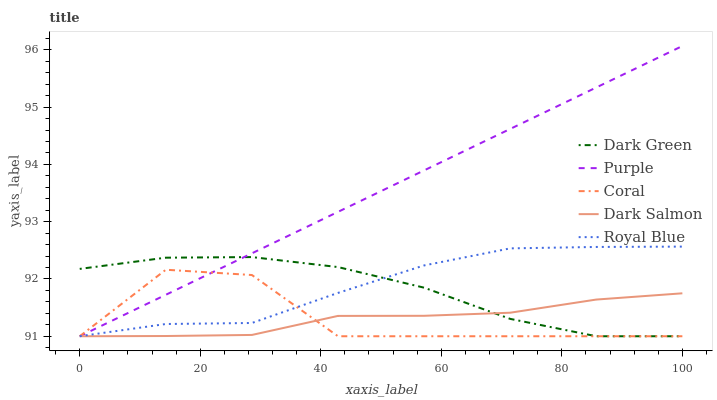Does Dark Salmon have the minimum area under the curve?
Answer yes or no. Yes. Does Purple have the maximum area under the curve?
Answer yes or no. Yes. Does Royal Blue have the minimum area under the curve?
Answer yes or no. No. Does Royal Blue have the maximum area under the curve?
Answer yes or no. No. Is Purple the smoothest?
Answer yes or no. Yes. Is Coral the roughest?
Answer yes or no. Yes. Is Royal Blue the smoothest?
Answer yes or no. No. Is Royal Blue the roughest?
Answer yes or no. No. Does Royal Blue have the lowest value?
Answer yes or no. No. Does Purple have the highest value?
Answer yes or no. Yes. Does Royal Blue have the highest value?
Answer yes or no. No. Is Dark Salmon less than Royal Blue?
Answer yes or no. Yes. Is Royal Blue greater than Dark Salmon?
Answer yes or no. Yes. Does Dark Green intersect Coral?
Answer yes or no. Yes. Is Dark Green less than Coral?
Answer yes or no. No. Is Dark Green greater than Coral?
Answer yes or no. No. Does Dark Salmon intersect Royal Blue?
Answer yes or no. No. 